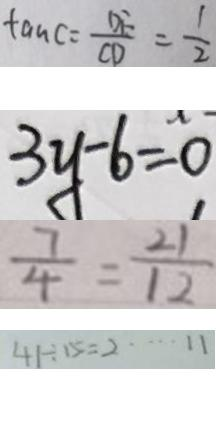Convert formula to latex. <formula><loc_0><loc_0><loc_500><loc_500>\tan C = \frac { D F } { C D } = \frac { 1 } { 2 } 
 3 y - 6 = 0 
 \frac { 7 } { 4 } = \frac { 2 1 } { 1 2 } 
 4 5 \div 1 5 = 2 \cdots 1 1</formula> 